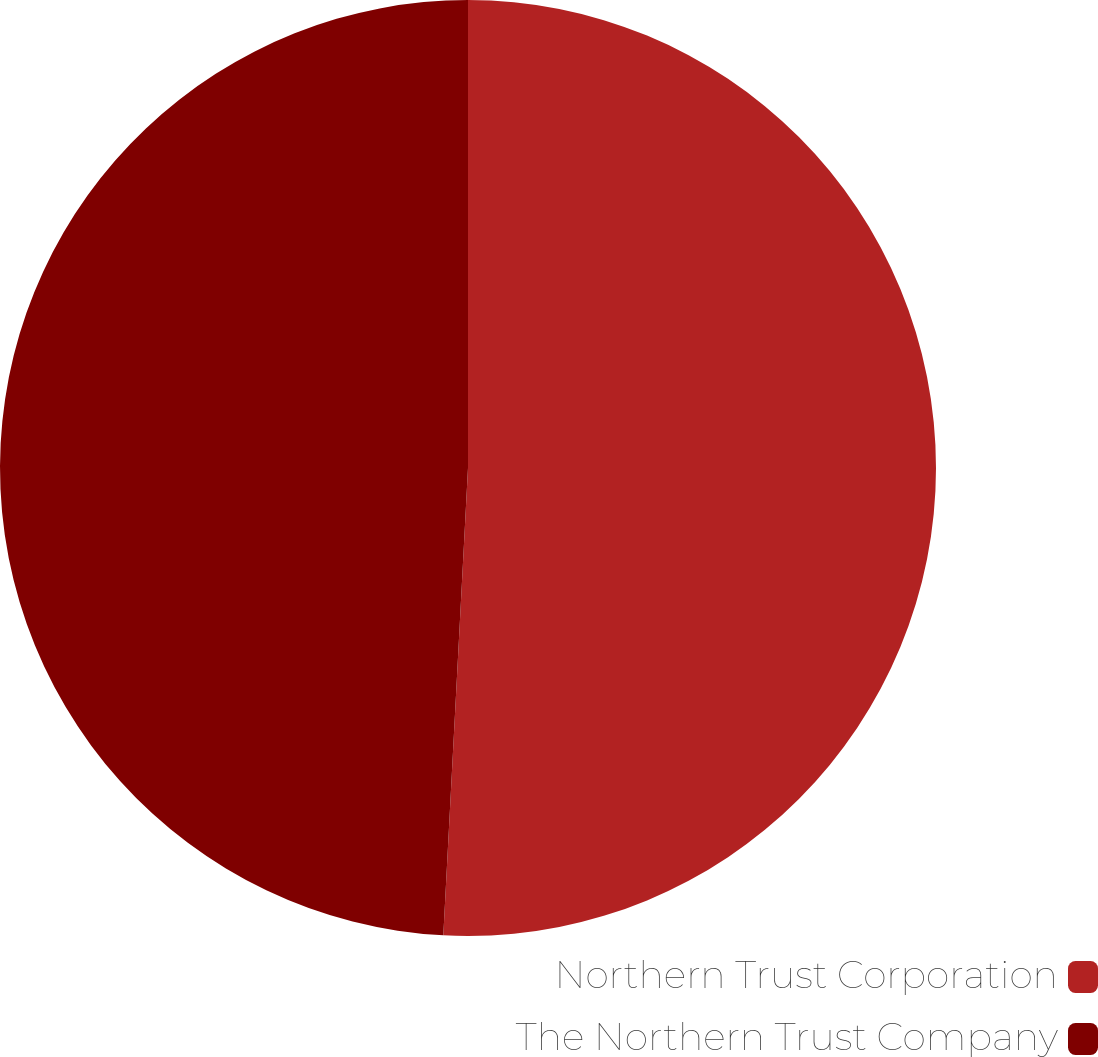Convert chart to OTSL. <chart><loc_0><loc_0><loc_500><loc_500><pie_chart><fcel>Northern Trust Corporation<fcel>The Northern Trust Company<nl><fcel>50.84%<fcel>49.16%<nl></chart> 